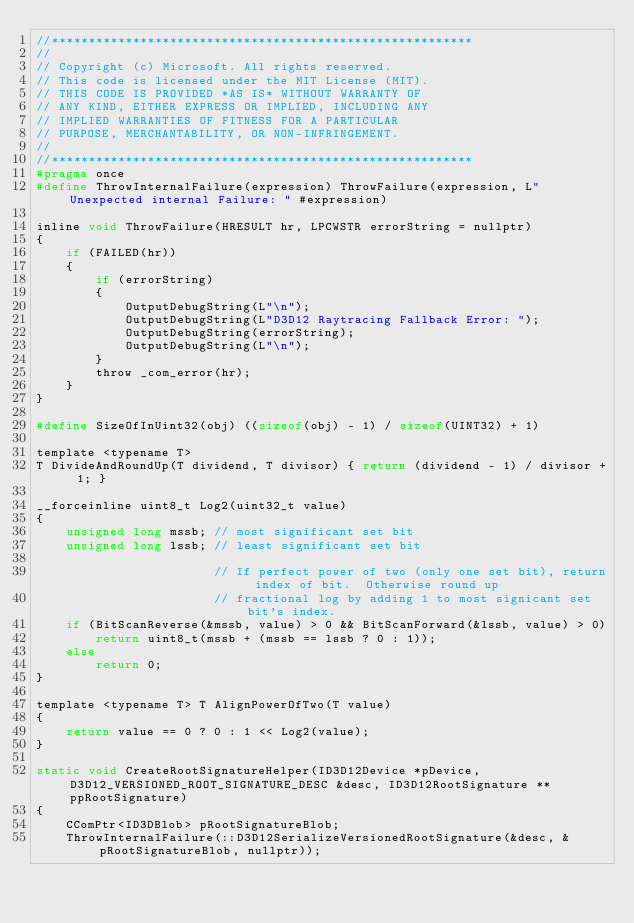Convert code to text. <code><loc_0><loc_0><loc_500><loc_500><_C_>//*********************************************************
//
// Copyright (c) Microsoft. All rights reserved.
// This code is licensed under the MIT License (MIT).
// THIS CODE IS PROVIDED *AS IS* WITHOUT WARRANTY OF
// ANY KIND, EITHER EXPRESS OR IMPLIED, INCLUDING ANY
// IMPLIED WARRANTIES OF FITNESS FOR A PARTICULAR
// PURPOSE, MERCHANTABILITY, OR NON-INFRINGEMENT.
//
//*********************************************************
#pragma once
#define ThrowInternalFailure(expression) ThrowFailure(expression, L"Unexpected internal Failure: " #expression)

inline void ThrowFailure(HRESULT hr, LPCWSTR errorString = nullptr)
{
    if (FAILED(hr))
    {
        if (errorString)
        {
            OutputDebugString(L"\n");
            OutputDebugString(L"D3D12 Raytracing Fallback Error: ");
            OutputDebugString(errorString);
            OutputDebugString(L"\n");
        }
        throw _com_error(hr);
    }
}

#define SizeOfInUint32(obj) ((sizeof(obj) - 1) / sizeof(UINT32) + 1)

template <typename T>
T DivideAndRoundUp(T dividend, T divisor) { return (dividend - 1) / divisor + 1; }

__forceinline uint8_t Log2(uint32_t value)
{
    unsigned long mssb; // most significant set bit
    unsigned long lssb; // least significant set bit

                        // If perfect power of two (only one set bit), return index of bit.  Otherwise round up
                        // fractional log by adding 1 to most signicant set bit's index.
    if (BitScanReverse(&mssb, value) > 0 && BitScanForward(&lssb, value) > 0)
        return uint8_t(mssb + (mssb == lssb ? 0 : 1));
    else
        return 0;
}

template <typename T> T AlignPowerOfTwo(T value)
{
    return value == 0 ? 0 : 1 << Log2(value);
}

static void CreateRootSignatureHelper(ID3D12Device *pDevice, D3D12_VERSIONED_ROOT_SIGNATURE_DESC &desc, ID3D12RootSignature **ppRootSignature)
{
    CComPtr<ID3DBlob> pRootSignatureBlob;
    ThrowInternalFailure(::D3D12SerializeVersionedRootSignature(&desc, &pRootSignatureBlob, nullptr));
</code> 